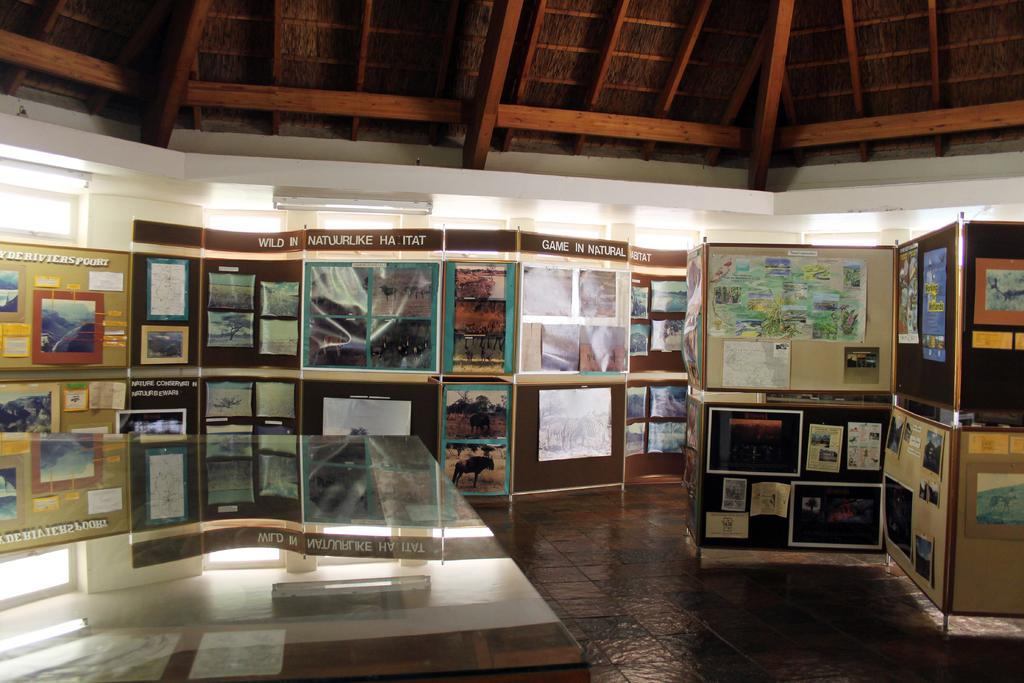What can be seen in the image that resembles vertical structures? There are posts in the image. What is attached to the wall in the image? There are photo frames and papers on a wall in the image. What type of illumination is visible in the image? There are lights visible in the image. What is covering the top of the scene in the image? There is a roof in the image. What is located at the bottom of the image? There is a table at the bottom of the image. Can you tell me where the river is located in the image? There is no river present in the image. What type of amusement can be seen in the image? There is no amusement depicted in the image. 